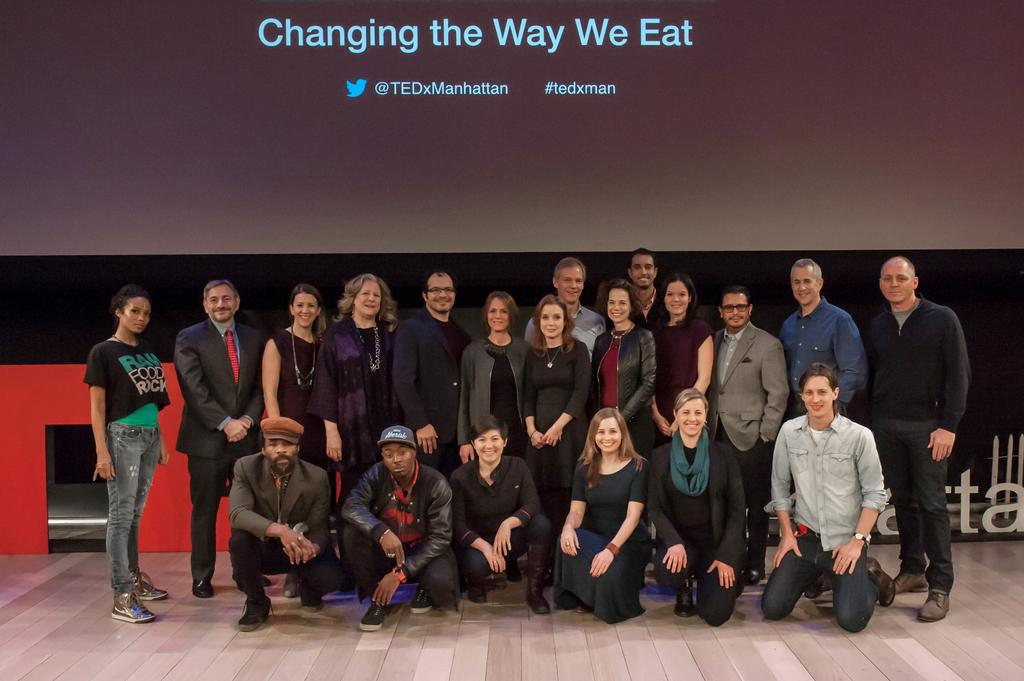What is happening on the stage in the image? There are people on the stage in the image. What can be seen behind the people on the stage? There is a screen with text visible behind the people on the stage. What type of hair is visible on the basin in the image? There is no basin or hair present in the image. What part of the body is visible on the screen behind the people on the stage? The text on the screen does not depict any part of the body; it is simply text. 